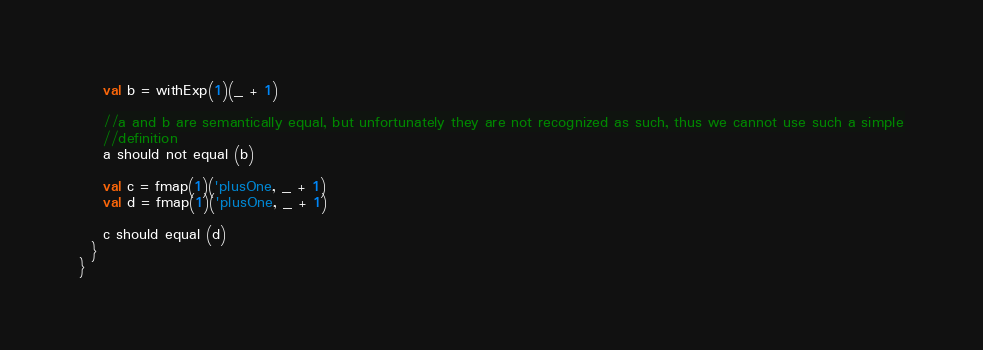<code> <loc_0><loc_0><loc_500><loc_500><_Scala_>    val b = withExp(1)(_ + 1)

    //a and b are semantically equal, but unfortunately they are not recognized as such, thus we cannot use such a simple
    //definition
    a should not equal (b)

    val c = fmap(1)('plusOne, _ + 1)
    val d = fmap(1)('plusOne, _ + 1)

    c should equal (d)
  }
}

</code> 